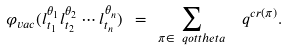Convert formula to latex. <formula><loc_0><loc_0><loc_500><loc_500>\varphi _ { v a c } ( l _ { t _ { 1 } } ^ { \theta _ { 1 } } l _ { t _ { 2 } } ^ { \theta _ { 2 } } \cdots l _ { t _ { n } } ^ { \theta _ { n } } ) \ = \ \sum _ { \pi \in \ q o t t h e t a } \ \ q ^ { c r ( \pi ) } .</formula> 